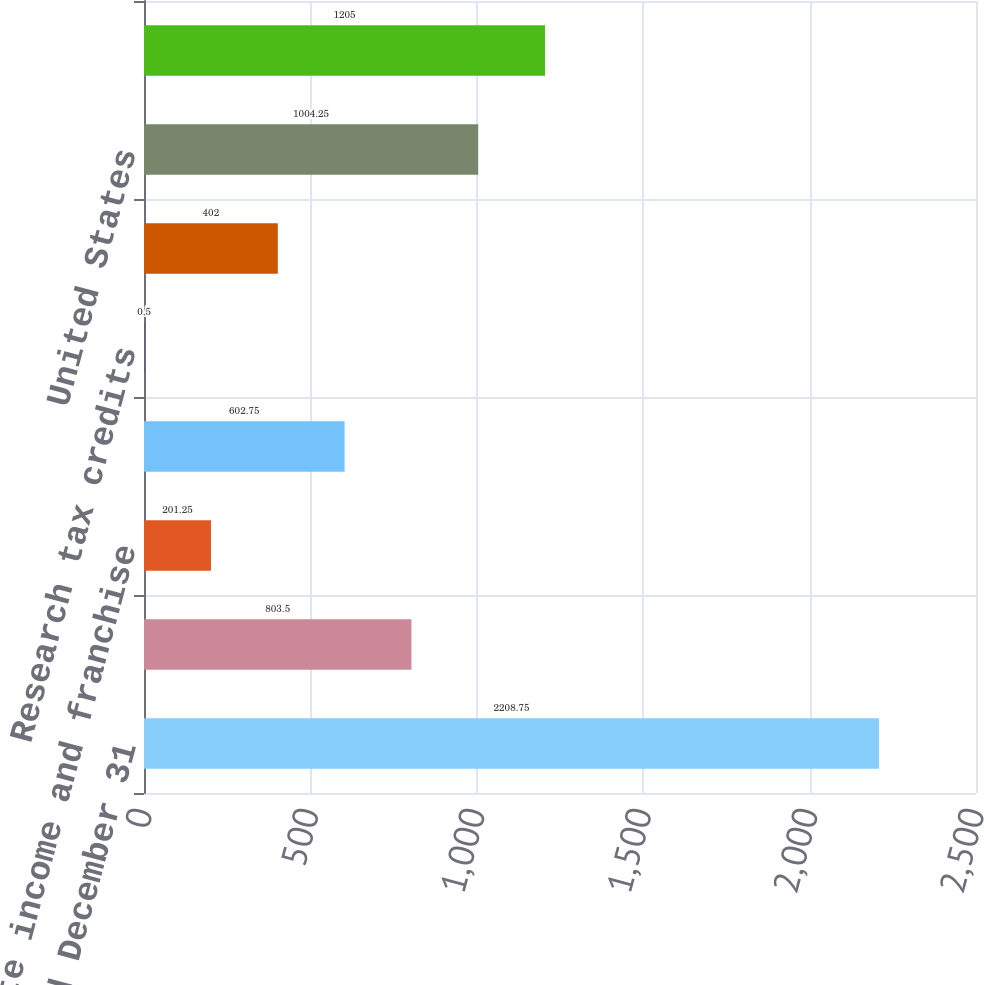Convert chart. <chart><loc_0><loc_0><loc_500><loc_500><bar_chart><fcel>Years ended December 31<fcel>Provision at US federal<fcel>State income and franchise<fcel>International income tax rate<fcel>Research tax credits<fcel>Other<fcel>United States<fcel>International<nl><fcel>2208.75<fcel>803.5<fcel>201.25<fcel>602.75<fcel>0.5<fcel>402<fcel>1004.25<fcel>1205<nl></chart> 